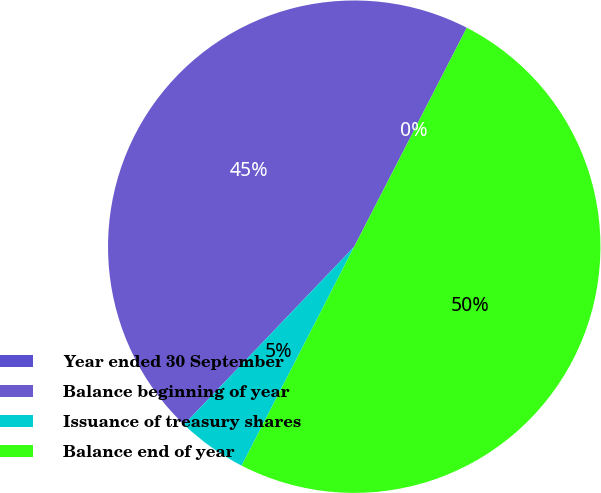Convert chart. <chart><loc_0><loc_0><loc_500><loc_500><pie_chart><fcel>Year ended 30 September<fcel>Balance beginning of year<fcel>Issuance of treasury shares<fcel>Balance end of year<nl><fcel>0.0%<fcel>45.41%<fcel>4.59%<fcel>50.0%<nl></chart> 